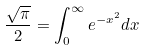<formula> <loc_0><loc_0><loc_500><loc_500>\frac { \sqrt { \pi } } { 2 } = \int _ { 0 } ^ { \infty } e ^ { - x ^ { 2 } } d x</formula> 